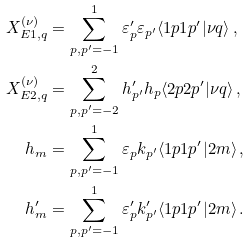<formula> <loc_0><loc_0><loc_500><loc_500>X _ { E 1 , q } ^ { ( \nu ) } & = \sum _ { p , p ^ { \prime } = - 1 } ^ { 1 } \varepsilon ^ { \prime } _ { p } \varepsilon _ { p ^ { \prime } } \langle 1 p 1 p ^ { \prime } | \nu q \rangle \, , \\ X _ { E 2 , q } ^ { ( \nu ) } & = \sum _ { p , p ^ { \prime } = - 2 } ^ { 2 } h ^ { \prime } _ { p ^ { \prime } } h _ { p } \langle 2 p 2 p ^ { \prime } | \nu q \rangle \, , \\ h _ { m } & = \sum _ { p , p ^ { \prime } = - 1 } ^ { 1 } \varepsilon _ { p } k _ { p ^ { \prime } } \langle 1 p 1 p ^ { \prime } | 2 m \rangle \, , \\ h ^ { \prime } _ { m } & = \sum _ { p , p ^ { \prime } = - 1 } ^ { 1 } \varepsilon ^ { \prime } _ { p } k ^ { \prime } _ { p ^ { \prime } } \langle 1 p 1 p ^ { \prime } | 2 m \rangle \, .</formula> 